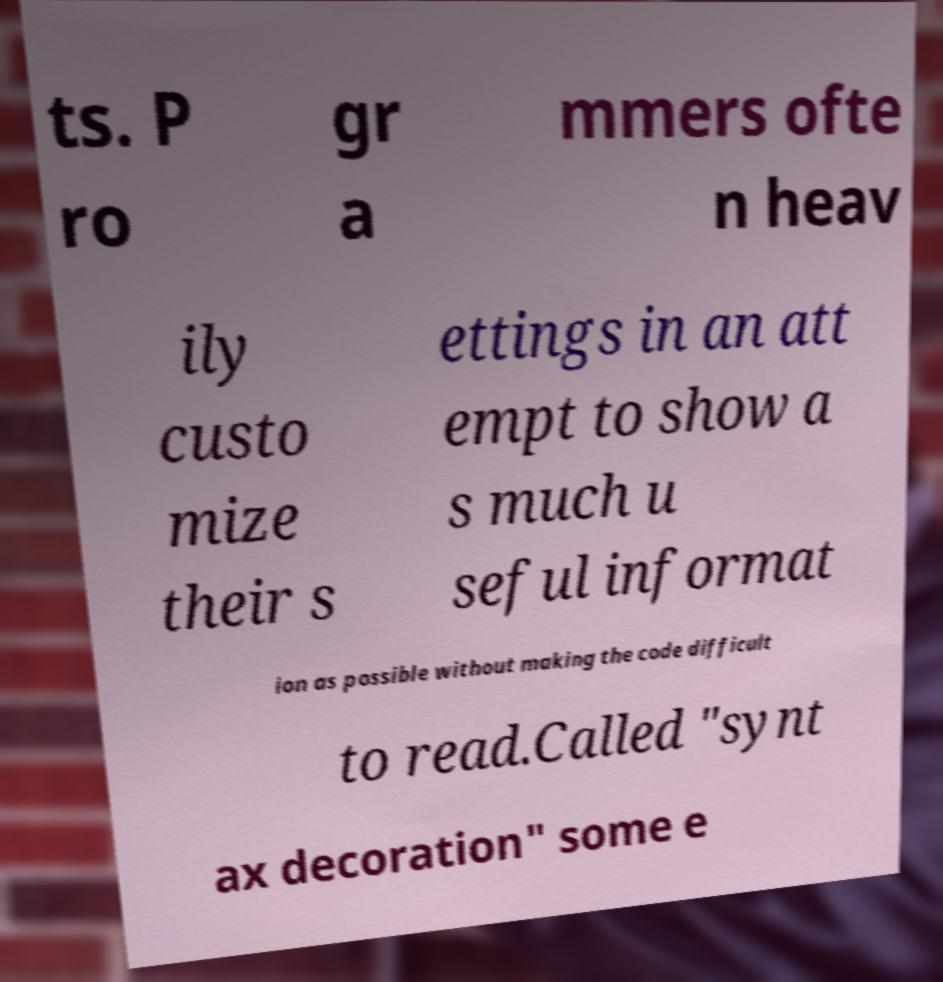Could you assist in decoding the text presented in this image and type it out clearly? ts. P ro gr a mmers ofte n heav ily custo mize their s ettings in an att empt to show a s much u seful informat ion as possible without making the code difficult to read.Called "synt ax decoration" some e 